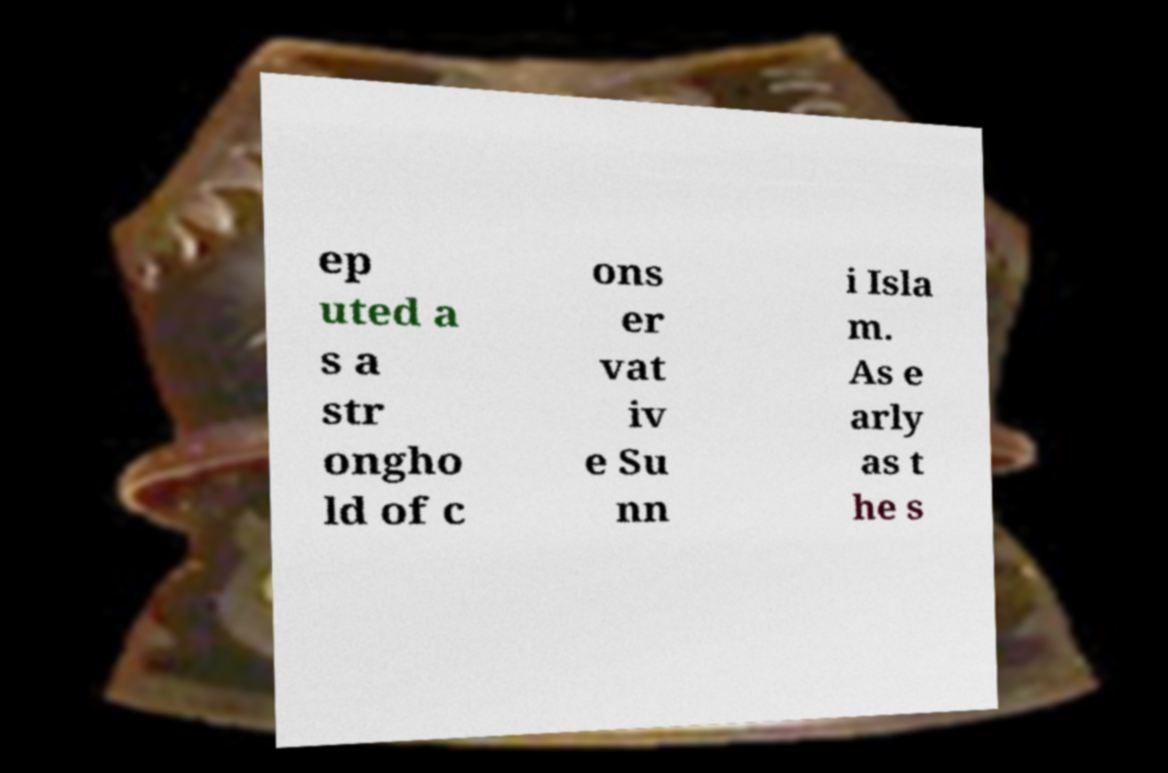There's text embedded in this image that I need extracted. Can you transcribe it verbatim? ep uted a s a str ongho ld of c ons er vat iv e Su nn i Isla m. As e arly as t he s 